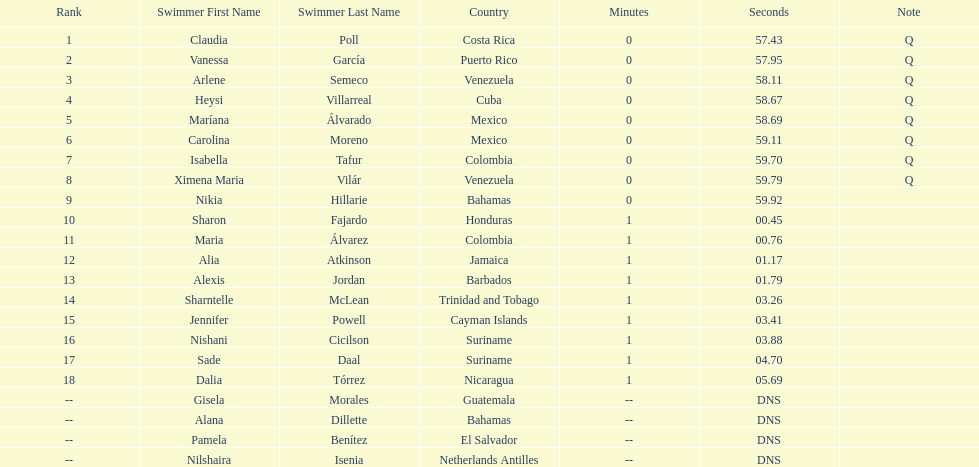How many swimmers did not swim? 4. 